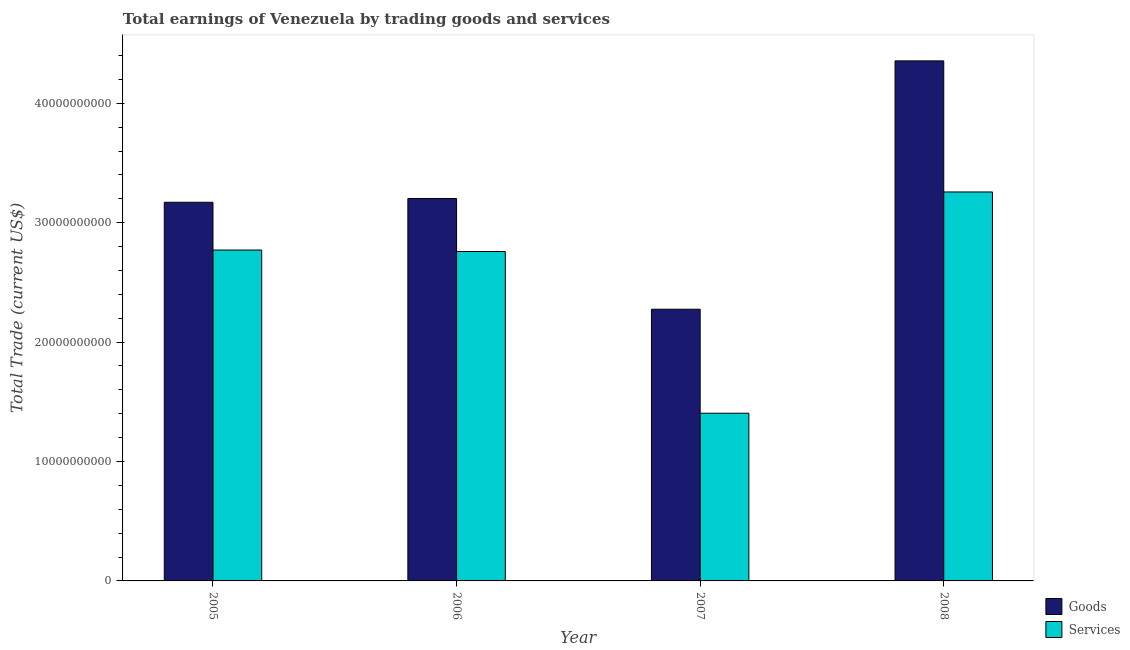How many different coloured bars are there?
Your answer should be very brief. 2. How many bars are there on the 2nd tick from the right?
Give a very brief answer. 2. In how many cases, is the number of bars for a given year not equal to the number of legend labels?
Offer a terse response. 0. What is the amount earned by trading goods in 2007?
Your answer should be compact. 2.28e+1. Across all years, what is the maximum amount earned by trading services?
Your answer should be compact. 3.26e+1. Across all years, what is the minimum amount earned by trading services?
Provide a succinct answer. 1.40e+1. In which year was the amount earned by trading services maximum?
Make the answer very short. 2008. What is the total amount earned by trading goods in the graph?
Make the answer very short. 1.30e+11. What is the difference between the amount earned by trading goods in 2006 and that in 2008?
Give a very brief answer. -1.15e+1. What is the difference between the amount earned by trading goods in 2006 and the amount earned by trading services in 2007?
Offer a very short reply. 9.27e+09. What is the average amount earned by trading goods per year?
Provide a short and direct response. 3.25e+1. What is the ratio of the amount earned by trading goods in 2005 to that in 2007?
Offer a terse response. 1.39. Is the amount earned by trading services in 2005 less than that in 2008?
Provide a short and direct response. Yes. What is the difference between the highest and the second highest amount earned by trading services?
Give a very brief answer. 4.86e+09. What is the difference between the highest and the lowest amount earned by trading goods?
Give a very brief answer. 2.08e+1. In how many years, is the amount earned by trading goods greater than the average amount earned by trading goods taken over all years?
Offer a terse response. 1. What does the 2nd bar from the left in 2007 represents?
Provide a short and direct response. Services. What does the 1st bar from the right in 2007 represents?
Ensure brevity in your answer.  Services. How many bars are there?
Ensure brevity in your answer.  8. Are all the bars in the graph horizontal?
Provide a succinct answer. No. What is the difference between two consecutive major ticks on the Y-axis?
Provide a short and direct response. 1.00e+1. Does the graph contain grids?
Keep it short and to the point. No. How are the legend labels stacked?
Make the answer very short. Vertical. What is the title of the graph?
Give a very brief answer. Total earnings of Venezuela by trading goods and services. What is the label or title of the X-axis?
Ensure brevity in your answer.  Year. What is the label or title of the Y-axis?
Provide a short and direct response. Total Trade (current US$). What is the Total Trade (current US$) of Goods in 2005?
Offer a very short reply. 3.17e+1. What is the Total Trade (current US$) in Services in 2005?
Offer a very short reply. 2.77e+1. What is the Total Trade (current US$) in Goods in 2006?
Your response must be concise. 3.20e+1. What is the Total Trade (current US$) of Services in 2006?
Keep it short and to the point. 2.76e+1. What is the Total Trade (current US$) in Goods in 2007?
Provide a short and direct response. 2.28e+1. What is the Total Trade (current US$) in Services in 2007?
Your answer should be compact. 1.40e+1. What is the Total Trade (current US$) in Goods in 2008?
Your answer should be compact. 4.36e+1. What is the Total Trade (current US$) in Services in 2008?
Offer a very short reply. 3.26e+1. Across all years, what is the maximum Total Trade (current US$) in Goods?
Provide a succinct answer. 4.36e+1. Across all years, what is the maximum Total Trade (current US$) in Services?
Provide a short and direct response. 3.26e+1. Across all years, what is the minimum Total Trade (current US$) of Goods?
Your answer should be compact. 2.28e+1. Across all years, what is the minimum Total Trade (current US$) of Services?
Make the answer very short. 1.40e+1. What is the total Total Trade (current US$) in Goods in the graph?
Offer a terse response. 1.30e+11. What is the total Total Trade (current US$) in Services in the graph?
Your answer should be very brief. 1.02e+11. What is the difference between the Total Trade (current US$) in Goods in 2005 and that in 2006?
Offer a terse response. -3.17e+08. What is the difference between the Total Trade (current US$) in Services in 2005 and that in 2006?
Make the answer very short. 1.26e+08. What is the difference between the Total Trade (current US$) in Goods in 2005 and that in 2007?
Keep it short and to the point. 8.96e+09. What is the difference between the Total Trade (current US$) of Services in 2005 and that in 2007?
Offer a very short reply. 1.37e+1. What is the difference between the Total Trade (current US$) in Goods in 2005 and that in 2008?
Offer a terse response. -1.18e+1. What is the difference between the Total Trade (current US$) in Services in 2005 and that in 2008?
Give a very brief answer. -4.86e+09. What is the difference between the Total Trade (current US$) of Goods in 2006 and that in 2007?
Offer a very short reply. 9.27e+09. What is the difference between the Total Trade (current US$) of Services in 2006 and that in 2007?
Your response must be concise. 1.35e+1. What is the difference between the Total Trade (current US$) in Goods in 2006 and that in 2008?
Your answer should be compact. -1.15e+1. What is the difference between the Total Trade (current US$) in Services in 2006 and that in 2008?
Offer a very short reply. -4.99e+09. What is the difference between the Total Trade (current US$) of Goods in 2007 and that in 2008?
Give a very brief answer. -2.08e+1. What is the difference between the Total Trade (current US$) in Services in 2007 and that in 2008?
Ensure brevity in your answer.  -1.85e+1. What is the difference between the Total Trade (current US$) of Goods in 2005 and the Total Trade (current US$) of Services in 2006?
Keep it short and to the point. 4.12e+09. What is the difference between the Total Trade (current US$) of Goods in 2005 and the Total Trade (current US$) of Services in 2007?
Provide a short and direct response. 1.77e+1. What is the difference between the Total Trade (current US$) in Goods in 2005 and the Total Trade (current US$) in Services in 2008?
Provide a succinct answer. -8.64e+08. What is the difference between the Total Trade (current US$) of Goods in 2006 and the Total Trade (current US$) of Services in 2007?
Your answer should be compact. 1.80e+1. What is the difference between the Total Trade (current US$) of Goods in 2006 and the Total Trade (current US$) of Services in 2008?
Your response must be concise. -5.47e+08. What is the difference between the Total Trade (current US$) in Goods in 2007 and the Total Trade (current US$) in Services in 2008?
Provide a short and direct response. -9.82e+09. What is the average Total Trade (current US$) in Goods per year?
Keep it short and to the point. 3.25e+1. What is the average Total Trade (current US$) of Services per year?
Make the answer very short. 2.55e+1. In the year 2005, what is the difference between the Total Trade (current US$) of Goods and Total Trade (current US$) of Services?
Offer a terse response. 4.00e+09. In the year 2006, what is the difference between the Total Trade (current US$) of Goods and Total Trade (current US$) of Services?
Give a very brief answer. 4.44e+09. In the year 2007, what is the difference between the Total Trade (current US$) in Goods and Total Trade (current US$) in Services?
Keep it short and to the point. 8.71e+09. In the year 2008, what is the difference between the Total Trade (current US$) in Goods and Total Trade (current US$) in Services?
Provide a succinct answer. 1.10e+1. What is the ratio of the Total Trade (current US$) in Services in 2005 to that in 2006?
Offer a terse response. 1. What is the ratio of the Total Trade (current US$) of Goods in 2005 to that in 2007?
Keep it short and to the point. 1.39. What is the ratio of the Total Trade (current US$) in Services in 2005 to that in 2007?
Ensure brevity in your answer.  1.97. What is the ratio of the Total Trade (current US$) of Goods in 2005 to that in 2008?
Provide a short and direct response. 0.73. What is the ratio of the Total Trade (current US$) of Services in 2005 to that in 2008?
Ensure brevity in your answer.  0.85. What is the ratio of the Total Trade (current US$) in Goods in 2006 to that in 2007?
Make the answer very short. 1.41. What is the ratio of the Total Trade (current US$) in Services in 2006 to that in 2007?
Your response must be concise. 1.96. What is the ratio of the Total Trade (current US$) of Goods in 2006 to that in 2008?
Offer a very short reply. 0.74. What is the ratio of the Total Trade (current US$) of Services in 2006 to that in 2008?
Provide a short and direct response. 0.85. What is the ratio of the Total Trade (current US$) in Goods in 2007 to that in 2008?
Ensure brevity in your answer.  0.52. What is the ratio of the Total Trade (current US$) of Services in 2007 to that in 2008?
Ensure brevity in your answer.  0.43. What is the difference between the highest and the second highest Total Trade (current US$) of Goods?
Provide a short and direct response. 1.15e+1. What is the difference between the highest and the second highest Total Trade (current US$) of Services?
Your response must be concise. 4.86e+09. What is the difference between the highest and the lowest Total Trade (current US$) in Goods?
Offer a very short reply. 2.08e+1. What is the difference between the highest and the lowest Total Trade (current US$) in Services?
Ensure brevity in your answer.  1.85e+1. 